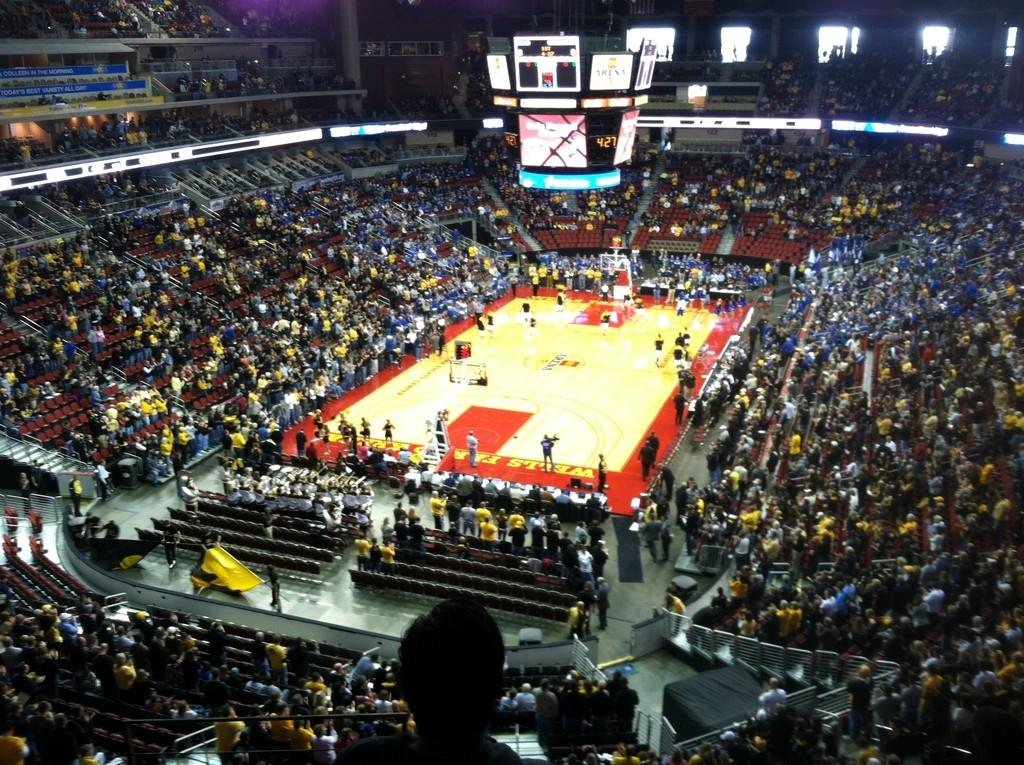Provide a one-sentence caption for the provided image. A basketball court has advertisements for Wells Fargo on either end of the hardwood floor. 